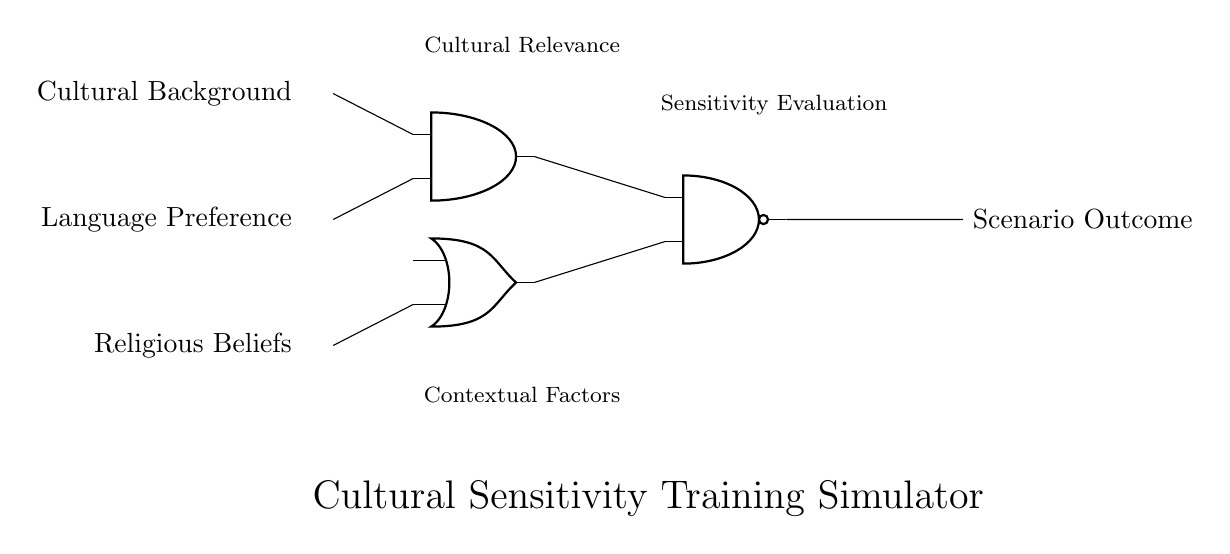What are the input scenarios represented in the circuit? The input scenarios are cultural background, language preference, and religious beliefs. These labels indicate the specific factors being evaluated for cultural sensitivity.
Answer: cultural background, language preference, religious beliefs What type of logic gate is used to combine cultural background and language preference? An AND gate is used to combine cultural background and language preference, as indicated by its position and label in the circuit diagram.
Answer: AND gate What is the output of the NAND gate based on the inputs? The output of the NAND gate will be the opposite of the output from the AND and OR gates. It evaluates the combined sensitivity evaluations and contextual factors.
Answer: Depends on inputs What determines the scenario outcome in this circuit? The scenario outcome is determined by the output of the NAND gate, which takes inputs from both the AND and OR gates representing different evaluations.
Answer: NAND gate output How many logic gates are present in the circuit? There are three logic gates in total: one AND gate, one OR gate, and one NAND gate as shown in the diagram.
Answer: three What does the AND gate output signify in this context? The output of the AND gate signifies that both cultural background and language preference factors are necessary for a specific sensitivity evaluation.
Answer: sensitivity evaluation Which logic gate is responsible for evaluating contextual factors? The OR gate is responsible for evaluating contextual factors, yielding an output when either of its inputs is true, which influences the scenario outcome.
Answer: OR gate 